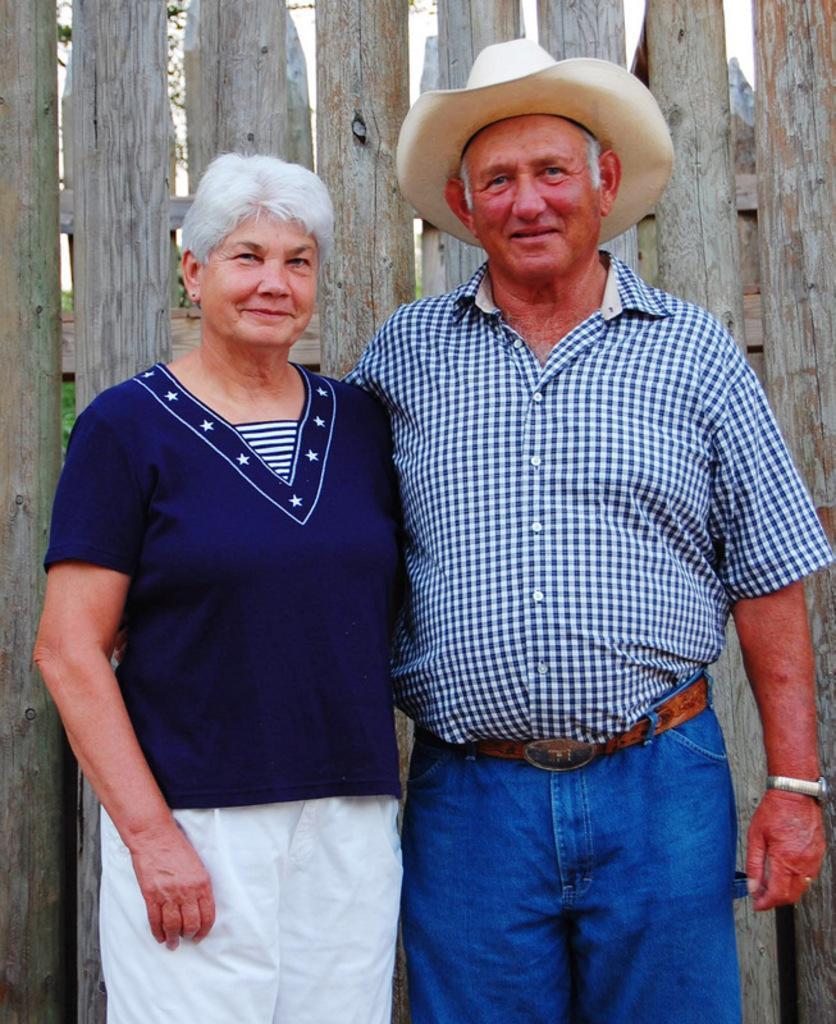In one or two sentences, can you explain what this image depicts? Here in this picture we can see a couple standing on the ground over there and the person on the right side is wearing a hat on him and behind them we can see a wooden railing present and through that we can see some trees over there. 